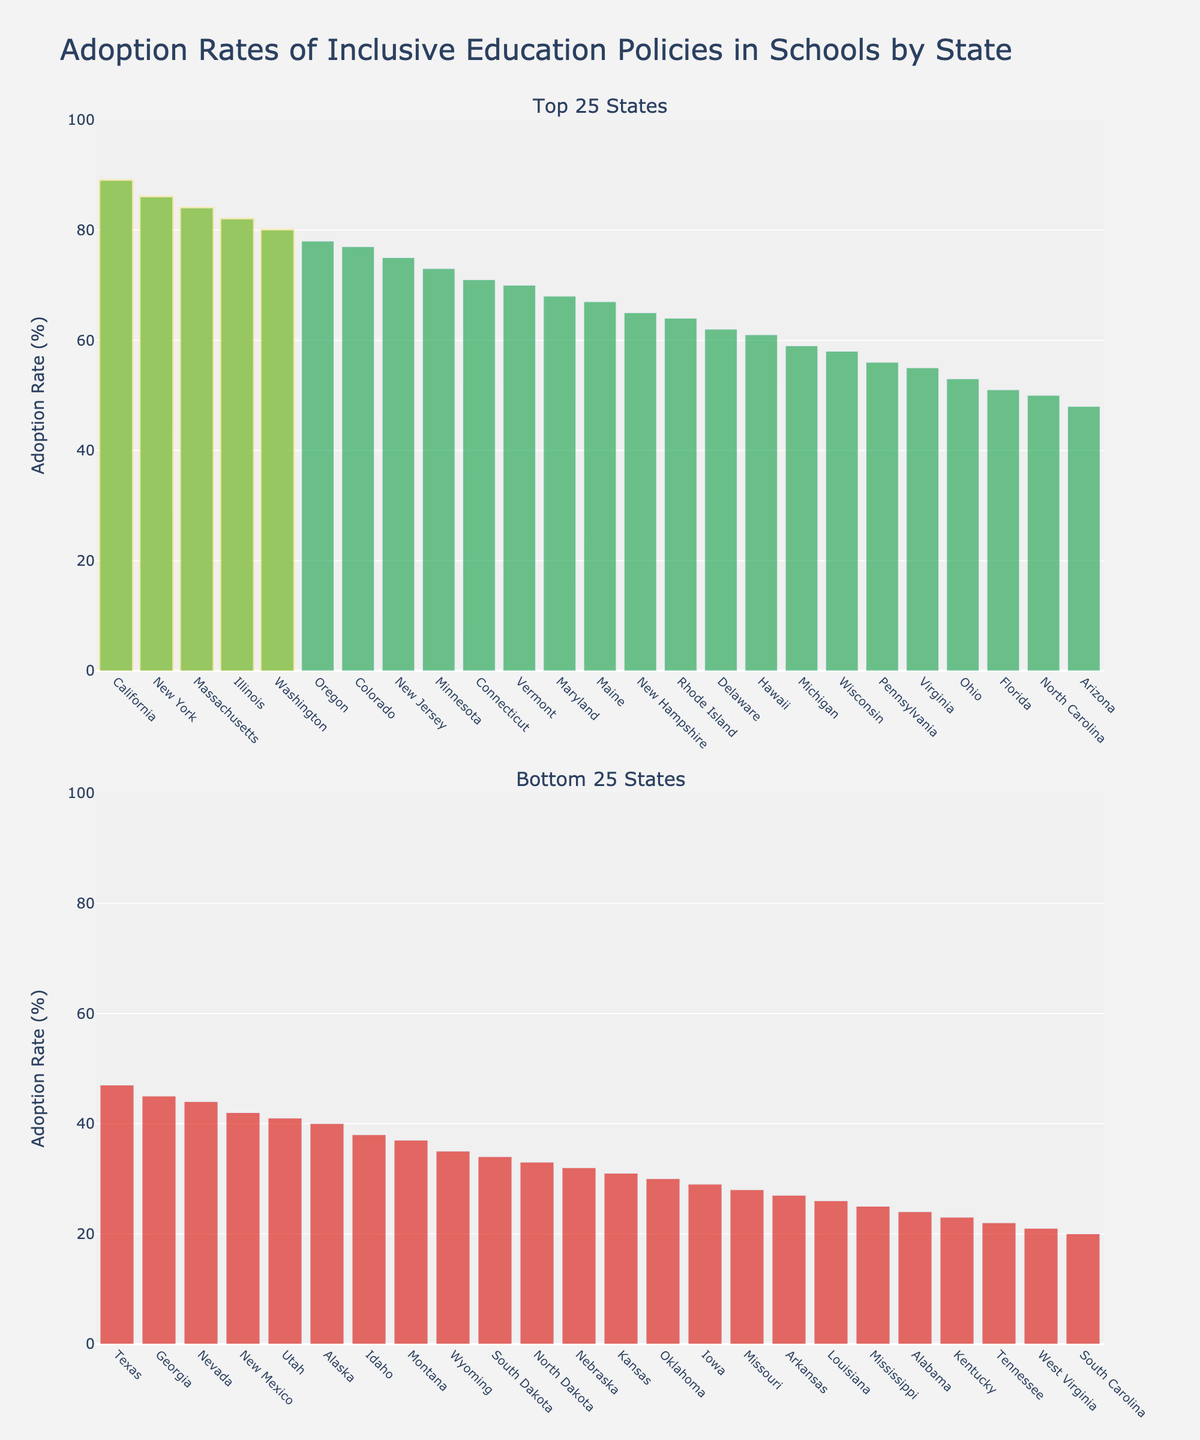Which state has the highest adoption rate of inclusive education policies? By looking at the height of the bars in the top 25 states, the tallest bar represents California with an 89% adoption rate.
Answer: California Which state has the lowest adoption rate of inclusive education policies? By looking at the height of the bars in the bottom 25 states, the shortest bar represents South Carolina with a 20% adoption rate.
Answer: South Carolina What is the difference in adoption rates between New York and Texas? New York has an adoption rate of 86%, and Texas has an adoption rate of 47%. The difference is 86 - 47 = 39%.
Answer: 39% How many states have adoption rates above 80%? The states above 80% are California, New York, Massachusetts, Illinois, and Washington, totaling 5 states.
Answer: 5 What is the average adoption rate of the top 5 states? The top 5 states have adoption rates of 89%, 86%, 84%, 82%, and 80%. Sum these rates: 89 + 86 + 84 + 82 + 80 = 421. Average is 421 / 5 = 84.2%.
Answer: 84.2% Which state has an adoption rate closest to the average of the bottom 25 states? First, sum the adoption rates of the bottom 25 states and divide by 25 to find the average. Major steps include:
(40+38+37+35+34+33+32+31+30+29+28+27+26+25+24+23+22+21+20) = 611.
Average of bottom 25 states = 611 / 25 = 24.44%.
Comparing each value to the average, Louisiana with 26% is the closest.
Answer: Louisiana What is the difference in adoption rates between Maryland and Nevada? Maryland has an adoption rate of 68%, and Nevada has an adoption rate of 44%. The difference is 68 - 44 = 24%.
Answer: 24% Which state in the bottom 25 has the highest adoption rate? By looking at the height of the bars in the bottom 25 states, the highest bar represents Michigan with a 59% adoption rate.
Answer: Michigan What is the combined adoption rate of Connecticut and Vermont? Connecticut has an adoption rate of 71%, and Vermont has an adoption rate of 70%. Combined is 71 + 70 = 141%.
Answer: 141% How many states have adoption rates below 50%? By counting the bars in both graphs that have heights representing less than 50%, there are 18 states: Arizona, Texas, Georgia, Nevada, New Mexico, Utah, Alaska, Idaho, Montana, Wyoming, South Dakota, North Dakota, Nebraska, Kansas, Oklahoma, Iowa, Missouri, Arkansas, Louisiana, Mississippi, Alabama, Kentucky, Tennessee, West Virginia, South Carolina.
Answer: 18 